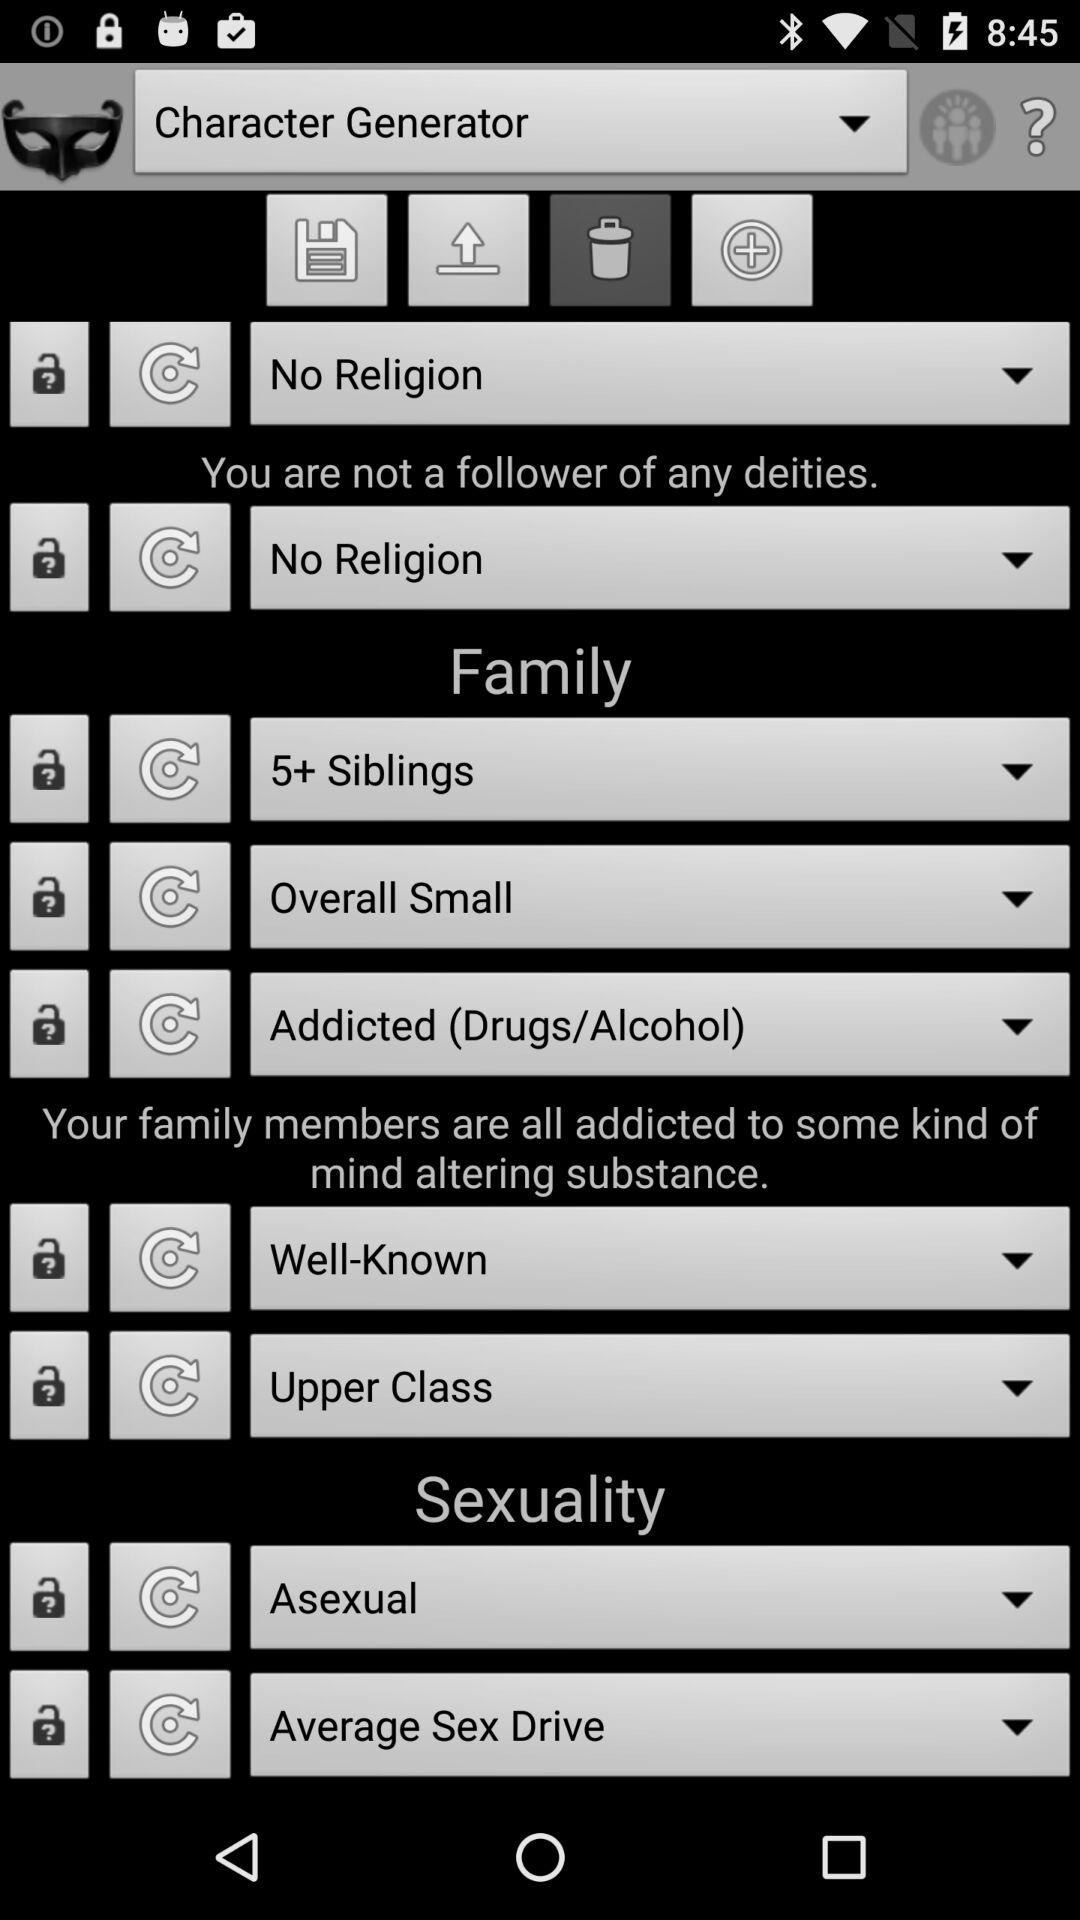How many siblings are there in the family? There are 5 or more siblings in the family. 